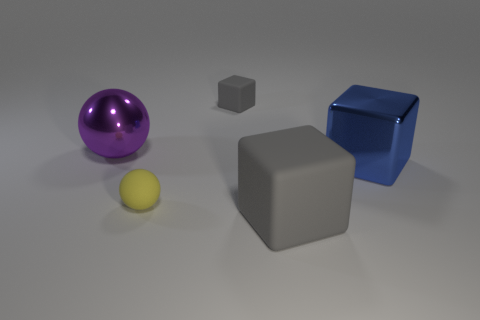Do the yellow sphere and the tiny gray object have the same material?
Your answer should be very brief. Yes. How many other things are the same color as the big rubber cube?
Offer a terse response. 1. What is the shape of the thing that is behind the big purple shiny object?
Make the answer very short. Cube. How many objects are either large gray rubber objects or small purple balls?
Keep it short and to the point. 1. There is a blue shiny object; is it the same size as the gray thing behind the large blue block?
Ensure brevity in your answer.  No. How many other things are there of the same material as the big sphere?
Provide a short and direct response. 1. How many things are either gray things in front of the tiny yellow ball or large objects that are in front of the large blue cube?
Give a very brief answer. 1. There is a yellow thing that is the same shape as the large purple metallic thing; what is its material?
Keep it short and to the point. Rubber. Are any big blue metal cubes visible?
Keep it short and to the point. Yes. How big is the thing that is both on the right side of the purple ball and behind the blue block?
Keep it short and to the point. Small. 